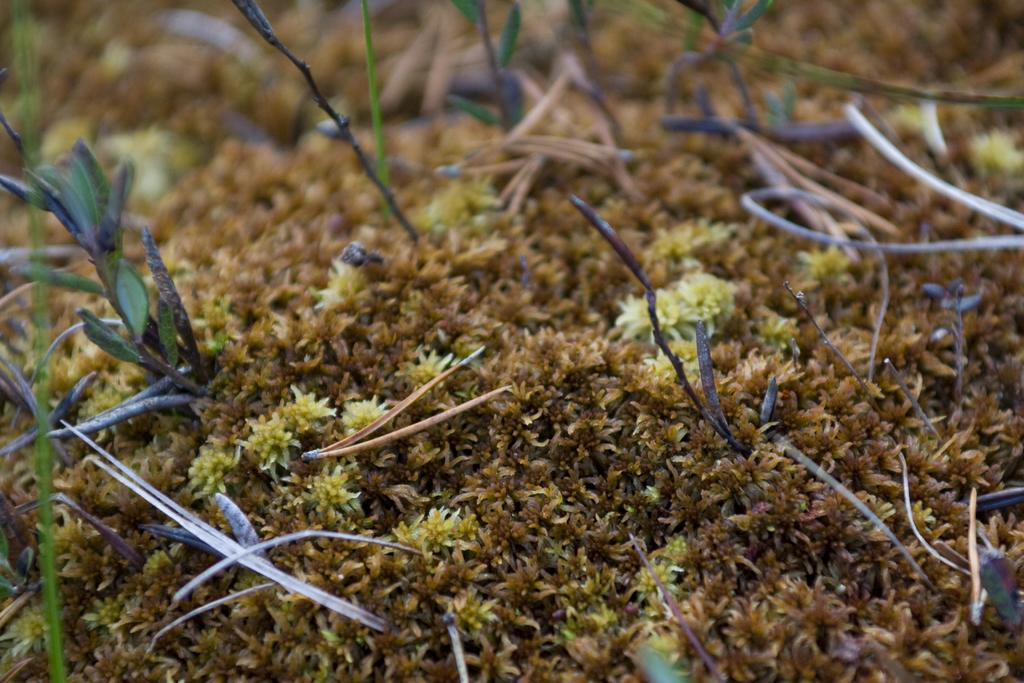What type of plant can be seen in the image? There is a plant moss in the image. What color is the sky in the image? There is no sky visible in the image; it only features a plant moss. Can you tell me how many friends are present in the image? There are no people or friends present in the image; it only features a plant moss. 